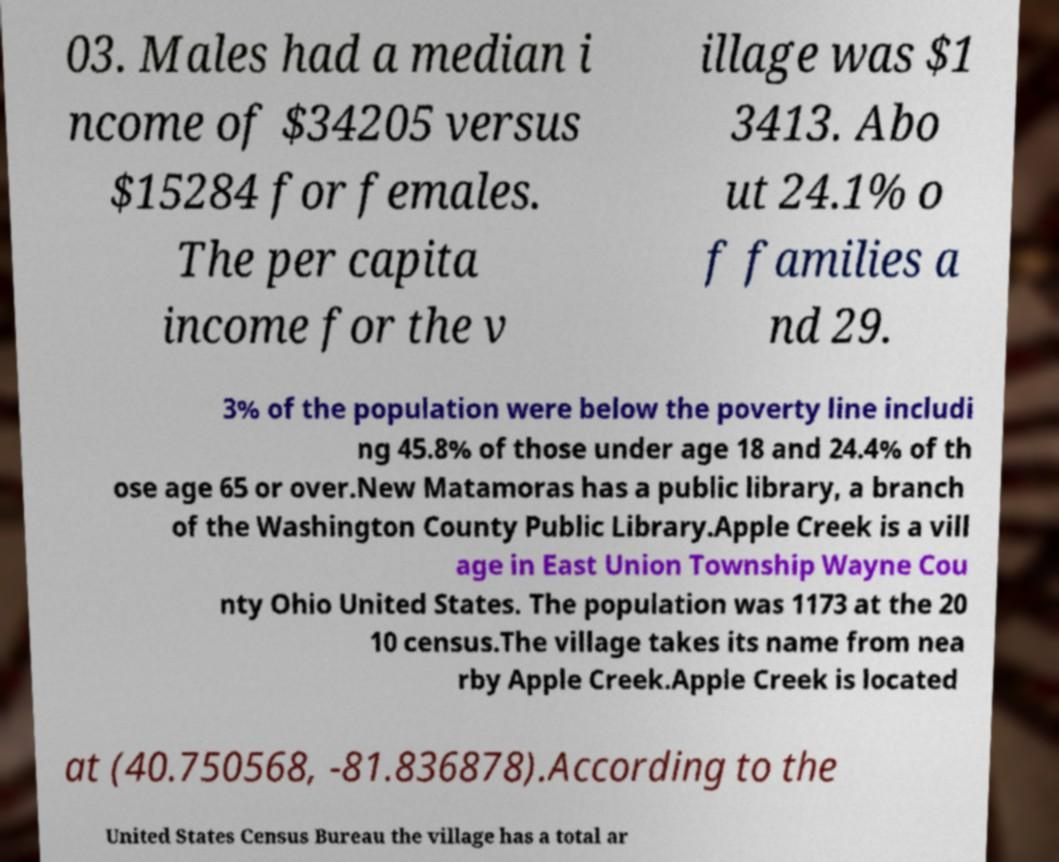What messages or text are displayed in this image? I need them in a readable, typed format. 03. Males had a median i ncome of $34205 versus $15284 for females. The per capita income for the v illage was $1 3413. Abo ut 24.1% o f families a nd 29. 3% of the population were below the poverty line includi ng 45.8% of those under age 18 and 24.4% of th ose age 65 or over.New Matamoras has a public library, a branch of the Washington County Public Library.Apple Creek is a vill age in East Union Township Wayne Cou nty Ohio United States. The population was 1173 at the 20 10 census.The village takes its name from nea rby Apple Creek.Apple Creek is located at (40.750568, -81.836878).According to the United States Census Bureau the village has a total ar 